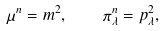<formula> <loc_0><loc_0><loc_500><loc_500>\mu ^ { n } = m ^ { 2 } , \quad \pi _ { \lambda } ^ { n } = p _ { \lambda } ^ { 2 } ,</formula> 